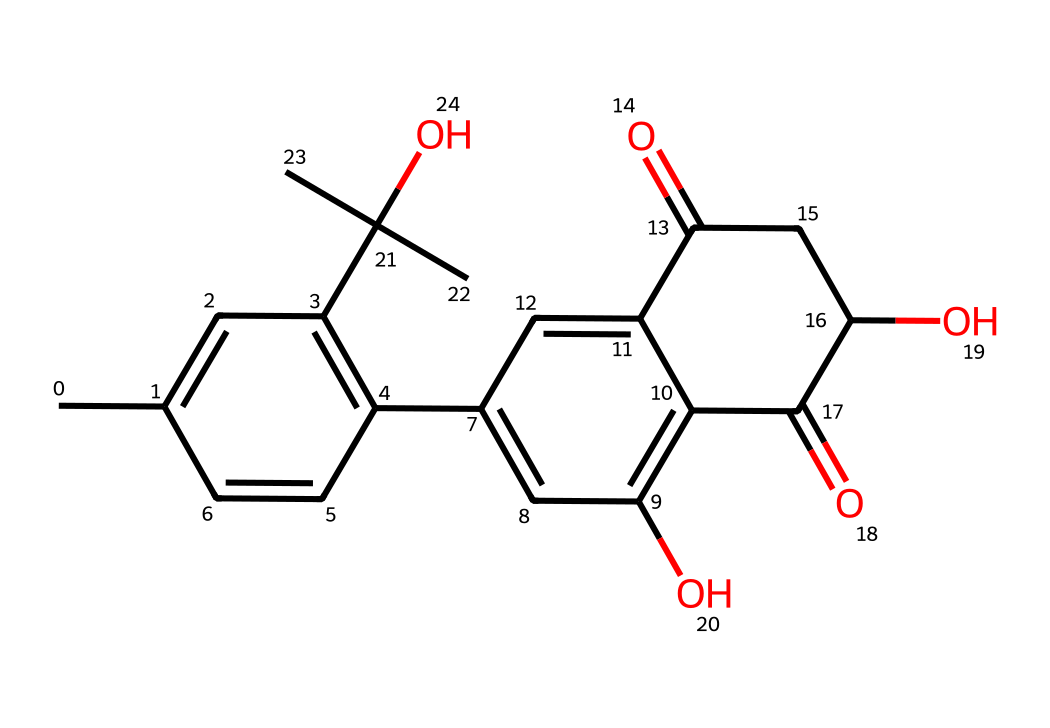How many carbons are in this chemical structure? By analyzing the SMILES representation, we see that there are multiple carbon atoms present without any carbon being specified with a number. Counting the 'C' directly in the SMILES leads us to a total of 21 carbon atoms in the molecule.
Answer: 21 What functional groups are present in this compound? Looking closely at the chemical structure represented by the SMILES, we can identify multiple functional groups such as -OH (hydroxyl) indicated by the 'O' attached to carbon atoms, and a ketone group (C=O) seen towards the center of the compound.
Answer: hydroxyl, ketone What is the molecular weight of this compound? To determine the molecular weight, we calculate the total contributions based on the count of various atoms from the chemical structure (C, H, O). For this compound, the molecular weight comes out to be approximately 318.36 g/mol.
Answer: 318.36 Does this chemical contain any aromatic rings? Looking at the structure, we see that there are multiple cyclic structures with alternating double bonds, indicating that it possesses aromatic properties due to the delocalized pi electrons within these structures.
Answer: yes What possible effects might this chemical have related to opioid addiction? This chemical, due to its cannabinoid structure, is speculated to interact with the endocannabinoid system which could help mitigate withdrawal symptoms and cravings associated with opioid addiction based on current research.
Answer: mitigate withdrawal What type of drug class does this compound belong to? Based on the functional groups and the overall structure, this chemical is categorized as a cannabinoid, utilized for its therapeutic effects. It suggests a role in modulating pain and could be beneficial in opioid dependence.
Answer: cannabinoid What specific interactions of this compound might help with pain management? This molecule can interact with cannabinoid receptors (CB1 and CB2) in the brain, which are known to play a role in pain modulation, leading to its potential analgesic effects when used therapeutically.
Answer: cannabinoid receptors 